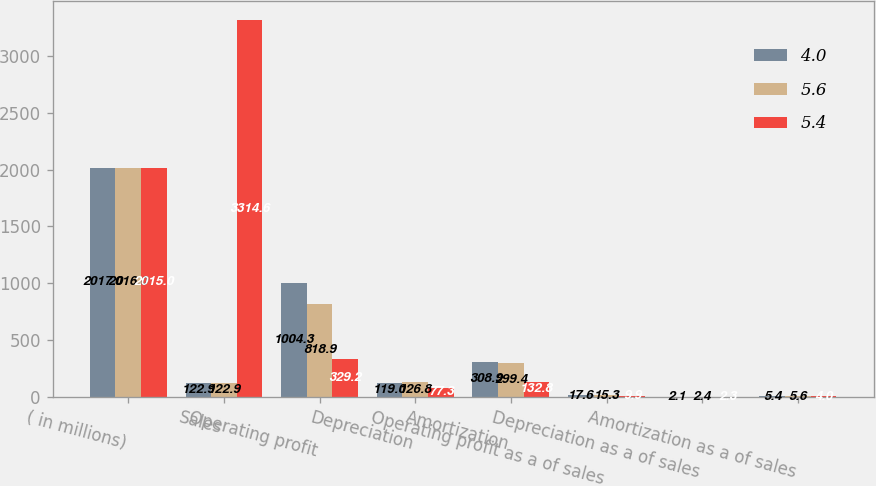Convert chart to OTSL. <chart><loc_0><loc_0><loc_500><loc_500><stacked_bar_chart><ecel><fcel>( in millions)<fcel>Sales<fcel>Operating profit<fcel>Depreciation<fcel>Amortization<fcel>Operating profit as a of sales<fcel>Depreciation as a of sales<fcel>Amortization as a of sales<nl><fcel>4<fcel>2017<fcel>122.9<fcel>1004.3<fcel>119<fcel>308.9<fcel>17.6<fcel>2.1<fcel>5.4<nl><fcel>5.6<fcel>2016<fcel>122.9<fcel>818.9<fcel>126.8<fcel>299.4<fcel>15.3<fcel>2.4<fcel>5.6<nl><fcel>5.4<fcel>2015<fcel>3314.6<fcel>329.2<fcel>77.3<fcel>132.8<fcel>9.9<fcel>2.3<fcel>4<nl></chart> 